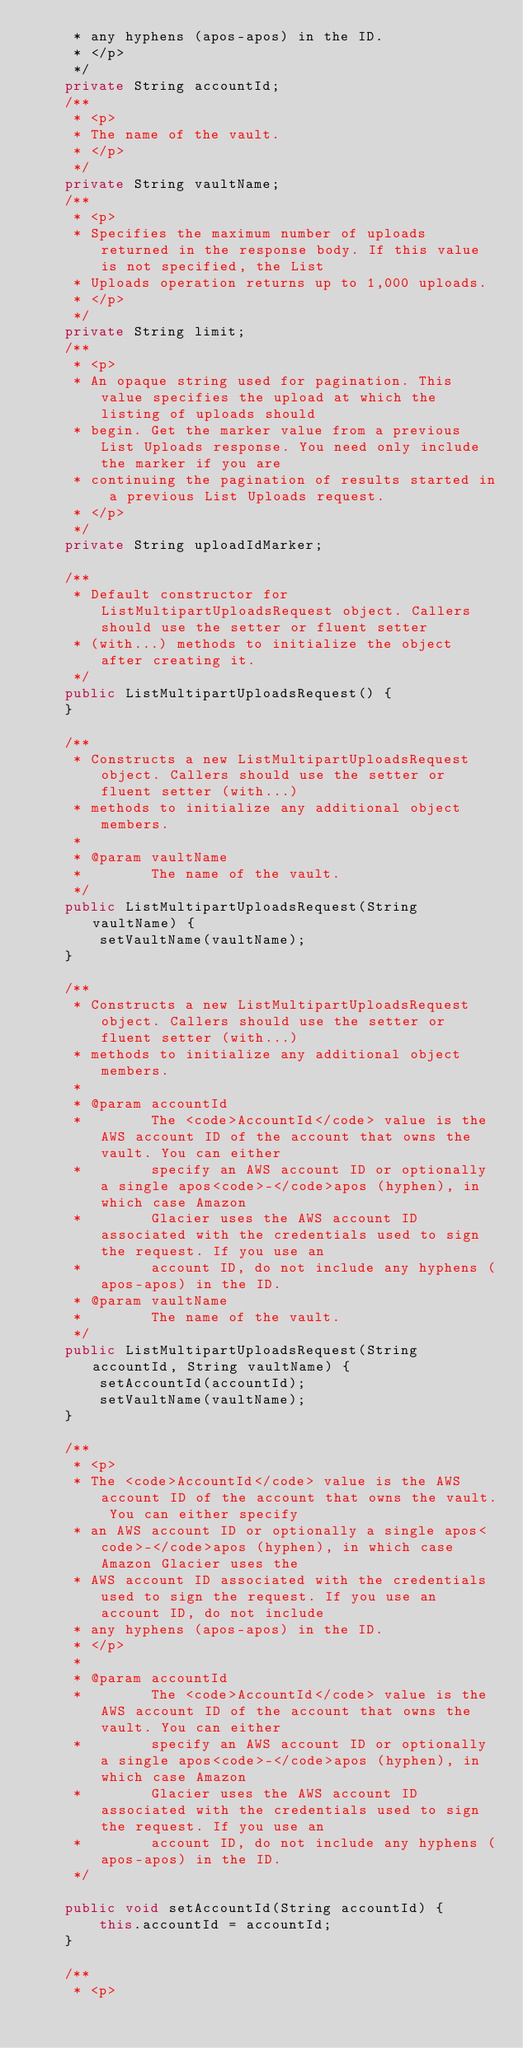Convert code to text. <code><loc_0><loc_0><loc_500><loc_500><_Java_>     * any hyphens (apos-apos) in the ID.
     * </p>
     */
    private String accountId;
    /**
     * <p>
     * The name of the vault.
     * </p>
     */
    private String vaultName;
    /**
     * <p>
     * Specifies the maximum number of uploads returned in the response body. If this value is not specified, the List
     * Uploads operation returns up to 1,000 uploads.
     * </p>
     */
    private String limit;
    /**
     * <p>
     * An opaque string used for pagination. This value specifies the upload at which the listing of uploads should
     * begin. Get the marker value from a previous List Uploads response. You need only include the marker if you are
     * continuing the pagination of results started in a previous List Uploads request.
     * </p>
     */
    private String uploadIdMarker;

    /**
     * Default constructor for ListMultipartUploadsRequest object. Callers should use the setter or fluent setter
     * (with...) methods to initialize the object after creating it.
     */
    public ListMultipartUploadsRequest() {
    }

    /**
     * Constructs a new ListMultipartUploadsRequest object. Callers should use the setter or fluent setter (with...)
     * methods to initialize any additional object members.
     * 
     * @param vaultName
     *        The name of the vault.
     */
    public ListMultipartUploadsRequest(String vaultName) {
        setVaultName(vaultName);
    }

    /**
     * Constructs a new ListMultipartUploadsRequest object. Callers should use the setter or fluent setter (with...)
     * methods to initialize any additional object members.
     * 
     * @param accountId
     *        The <code>AccountId</code> value is the AWS account ID of the account that owns the vault. You can either
     *        specify an AWS account ID or optionally a single apos<code>-</code>apos (hyphen), in which case Amazon
     *        Glacier uses the AWS account ID associated with the credentials used to sign the request. If you use an
     *        account ID, do not include any hyphens (apos-apos) in the ID.
     * @param vaultName
     *        The name of the vault.
     */
    public ListMultipartUploadsRequest(String accountId, String vaultName) {
        setAccountId(accountId);
        setVaultName(vaultName);
    }

    /**
     * <p>
     * The <code>AccountId</code> value is the AWS account ID of the account that owns the vault. You can either specify
     * an AWS account ID or optionally a single apos<code>-</code>apos (hyphen), in which case Amazon Glacier uses the
     * AWS account ID associated with the credentials used to sign the request. If you use an account ID, do not include
     * any hyphens (apos-apos) in the ID.
     * </p>
     * 
     * @param accountId
     *        The <code>AccountId</code> value is the AWS account ID of the account that owns the vault. You can either
     *        specify an AWS account ID or optionally a single apos<code>-</code>apos (hyphen), in which case Amazon
     *        Glacier uses the AWS account ID associated with the credentials used to sign the request. If you use an
     *        account ID, do not include any hyphens (apos-apos) in the ID.
     */

    public void setAccountId(String accountId) {
        this.accountId = accountId;
    }

    /**
     * <p></code> 